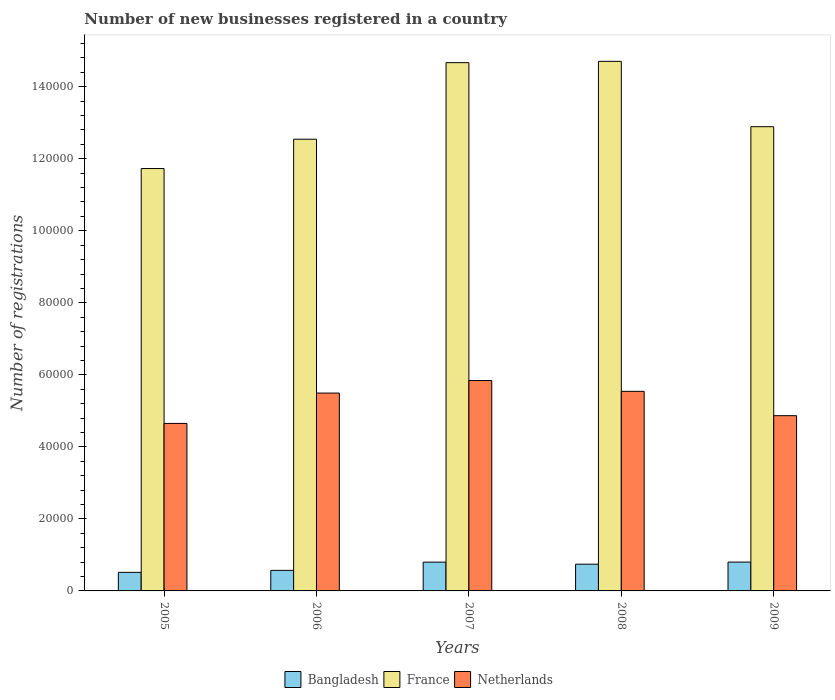How many different coloured bars are there?
Your answer should be very brief. 3. How many groups of bars are there?
Your response must be concise. 5. Are the number of bars per tick equal to the number of legend labels?
Give a very brief answer. Yes. Are the number of bars on each tick of the X-axis equal?
Provide a short and direct response. Yes. How many bars are there on the 5th tick from the left?
Offer a very short reply. 3. How many bars are there on the 1st tick from the right?
Ensure brevity in your answer.  3. What is the label of the 1st group of bars from the left?
Your answer should be compact. 2005. In how many cases, is the number of bars for a given year not equal to the number of legend labels?
Provide a short and direct response. 0. What is the number of new businesses registered in Netherlands in 2009?
Make the answer very short. 4.87e+04. Across all years, what is the maximum number of new businesses registered in Netherlands?
Make the answer very short. 5.84e+04. Across all years, what is the minimum number of new businesses registered in France?
Your response must be concise. 1.17e+05. In which year was the number of new businesses registered in France minimum?
Your answer should be very brief. 2005. What is the total number of new businesses registered in Netherlands in the graph?
Offer a terse response. 2.64e+05. What is the difference between the number of new businesses registered in France in 2006 and that in 2008?
Your response must be concise. -2.16e+04. What is the difference between the number of new businesses registered in Netherlands in 2005 and the number of new businesses registered in Bangladesh in 2006?
Your answer should be very brief. 4.08e+04. What is the average number of new businesses registered in Netherlands per year?
Ensure brevity in your answer.  5.28e+04. In the year 2008, what is the difference between the number of new businesses registered in Netherlands and number of new businesses registered in Bangladesh?
Keep it short and to the point. 4.80e+04. In how many years, is the number of new businesses registered in France greater than 124000?
Ensure brevity in your answer.  4. What is the ratio of the number of new businesses registered in Bangladesh in 2005 to that in 2008?
Offer a very short reply. 0.69. Is the number of new businesses registered in France in 2006 less than that in 2008?
Your answer should be compact. Yes. What is the difference between the highest and the lowest number of new businesses registered in Netherlands?
Give a very brief answer. 1.19e+04. In how many years, is the number of new businesses registered in Bangladesh greater than the average number of new businesses registered in Bangladesh taken over all years?
Provide a short and direct response. 3. Is the sum of the number of new businesses registered in Netherlands in 2006 and 2008 greater than the maximum number of new businesses registered in Bangladesh across all years?
Your answer should be very brief. Yes. What does the 1st bar from the left in 2008 represents?
Provide a short and direct response. Bangladesh. Is it the case that in every year, the sum of the number of new businesses registered in France and number of new businesses registered in Netherlands is greater than the number of new businesses registered in Bangladesh?
Your response must be concise. Yes. Are all the bars in the graph horizontal?
Your answer should be very brief. No. How many years are there in the graph?
Keep it short and to the point. 5. Are the values on the major ticks of Y-axis written in scientific E-notation?
Make the answer very short. No. Where does the legend appear in the graph?
Keep it short and to the point. Bottom center. How are the legend labels stacked?
Your answer should be compact. Horizontal. What is the title of the graph?
Keep it short and to the point. Number of new businesses registered in a country. Does "Guyana" appear as one of the legend labels in the graph?
Provide a short and direct response. No. What is the label or title of the X-axis?
Offer a very short reply. Years. What is the label or title of the Y-axis?
Ensure brevity in your answer.  Number of registrations. What is the Number of registrations of Bangladesh in 2005?
Keep it short and to the point. 5157. What is the Number of registrations of France in 2005?
Provide a succinct answer. 1.17e+05. What is the Number of registrations in Netherlands in 2005?
Give a very brief answer. 4.65e+04. What is the Number of registrations of Bangladesh in 2006?
Your response must be concise. 5707. What is the Number of registrations in France in 2006?
Your answer should be very brief. 1.25e+05. What is the Number of registrations of Netherlands in 2006?
Ensure brevity in your answer.  5.49e+04. What is the Number of registrations of Bangladesh in 2007?
Provide a short and direct response. 7992. What is the Number of registrations of France in 2007?
Ensure brevity in your answer.  1.47e+05. What is the Number of registrations in Netherlands in 2007?
Offer a very short reply. 5.84e+04. What is the Number of registrations of Bangladesh in 2008?
Give a very brief answer. 7425. What is the Number of registrations in France in 2008?
Your answer should be compact. 1.47e+05. What is the Number of registrations of Netherlands in 2008?
Make the answer very short. 5.54e+04. What is the Number of registrations of Bangladesh in 2009?
Make the answer very short. 8007. What is the Number of registrations in France in 2009?
Provide a short and direct response. 1.29e+05. What is the Number of registrations of Netherlands in 2009?
Provide a short and direct response. 4.87e+04. Across all years, what is the maximum Number of registrations in Bangladesh?
Provide a succinct answer. 8007. Across all years, what is the maximum Number of registrations in France?
Your answer should be very brief. 1.47e+05. Across all years, what is the maximum Number of registrations of Netherlands?
Ensure brevity in your answer.  5.84e+04. Across all years, what is the minimum Number of registrations of Bangladesh?
Ensure brevity in your answer.  5157. Across all years, what is the minimum Number of registrations in France?
Give a very brief answer. 1.17e+05. Across all years, what is the minimum Number of registrations of Netherlands?
Give a very brief answer. 4.65e+04. What is the total Number of registrations in Bangladesh in the graph?
Make the answer very short. 3.43e+04. What is the total Number of registrations in France in the graph?
Provide a short and direct response. 6.65e+05. What is the total Number of registrations in Netherlands in the graph?
Provide a short and direct response. 2.64e+05. What is the difference between the Number of registrations in Bangladesh in 2005 and that in 2006?
Make the answer very short. -550. What is the difference between the Number of registrations in France in 2005 and that in 2006?
Offer a terse response. -8145. What is the difference between the Number of registrations of Netherlands in 2005 and that in 2006?
Provide a succinct answer. -8426. What is the difference between the Number of registrations in Bangladesh in 2005 and that in 2007?
Offer a terse response. -2835. What is the difference between the Number of registrations of France in 2005 and that in 2007?
Offer a very short reply. -2.94e+04. What is the difference between the Number of registrations of Netherlands in 2005 and that in 2007?
Offer a very short reply. -1.19e+04. What is the difference between the Number of registrations of Bangladesh in 2005 and that in 2008?
Give a very brief answer. -2268. What is the difference between the Number of registrations in France in 2005 and that in 2008?
Make the answer very short. -2.98e+04. What is the difference between the Number of registrations in Netherlands in 2005 and that in 2008?
Ensure brevity in your answer.  -8905. What is the difference between the Number of registrations of Bangladesh in 2005 and that in 2009?
Provide a succinct answer. -2850. What is the difference between the Number of registrations in France in 2005 and that in 2009?
Offer a very short reply. -1.16e+04. What is the difference between the Number of registrations in Netherlands in 2005 and that in 2009?
Provide a succinct answer. -2146. What is the difference between the Number of registrations in Bangladesh in 2006 and that in 2007?
Keep it short and to the point. -2285. What is the difference between the Number of registrations of France in 2006 and that in 2007?
Provide a short and direct response. -2.13e+04. What is the difference between the Number of registrations in Netherlands in 2006 and that in 2007?
Give a very brief answer. -3487. What is the difference between the Number of registrations in Bangladesh in 2006 and that in 2008?
Offer a very short reply. -1718. What is the difference between the Number of registrations in France in 2006 and that in 2008?
Your response must be concise. -2.16e+04. What is the difference between the Number of registrations of Netherlands in 2006 and that in 2008?
Give a very brief answer. -479. What is the difference between the Number of registrations of Bangladesh in 2006 and that in 2009?
Your answer should be compact. -2300. What is the difference between the Number of registrations in France in 2006 and that in 2009?
Give a very brief answer. -3477. What is the difference between the Number of registrations of Netherlands in 2006 and that in 2009?
Keep it short and to the point. 6280. What is the difference between the Number of registrations in Bangladesh in 2007 and that in 2008?
Provide a short and direct response. 567. What is the difference between the Number of registrations of France in 2007 and that in 2008?
Ensure brevity in your answer.  -363. What is the difference between the Number of registrations in Netherlands in 2007 and that in 2008?
Give a very brief answer. 3008. What is the difference between the Number of registrations in France in 2007 and that in 2009?
Give a very brief answer. 1.78e+04. What is the difference between the Number of registrations of Netherlands in 2007 and that in 2009?
Provide a succinct answer. 9767. What is the difference between the Number of registrations in Bangladesh in 2008 and that in 2009?
Keep it short and to the point. -582. What is the difference between the Number of registrations in France in 2008 and that in 2009?
Offer a terse response. 1.81e+04. What is the difference between the Number of registrations in Netherlands in 2008 and that in 2009?
Your answer should be very brief. 6759. What is the difference between the Number of registrations of Bangladesh in 2005 and the Number of registrations of France in 2006?
Provide a succinct answer. -1.20e+05. What is the difference between the Number of registrations in Bangladesh in 2005 and the Number of registrations in Netherlands in 2006?
Make the answer very short. -4.98e+04. What is the difference between the Number of registrations of France in 2005 and the Number of registrations of Netherlands in 2006?
Keep it short and to the point. 6.23e+04. What is the difference between the Number of registrations in Bangladesh in 2005 and the Number of registrations in France in 2007?
Your response must be concise. -1.42e+05. What is the difference between the Number of registrations of Bangladesh in 2005 and the Number of registrations of Netherlands in 2007?
Provide a short and direct response. -5.33e+04. What is the difference between the Number of registrations of France in 2005 and the Number of registrations of Netherlands in 2007?
Ensure brevity in your answer.  5.89e+04. What is the difference between the Number of registrations of Bangladesh in 2005 and the Number of registrations of France in 2008?
Make the answer very short. -1.42e+05. What is the difference between the Number of registrations in Bangladesh in 2005 and the Number of registrations in Netherlands in 2008?
Keep it short and to the point. -5.03e+04. What is the difference between the Number of registrations in France in 2005 and the Number of registrations in Netherlands in 2008?
Your answer should be compact. 6.19e+04. What is the difference between the Number of registrations in Bangladesh in 2005 and the Number of registrations in France in 2009?
Make the answer very short. -1.24e+05. What is the difference between the Number of registrations of Bangladesh in 2005 and the Number of registrations of Netherlands in 2009?
Your answer should be compact. -4.35e+04. What is the difference between the Number of registrations in France in 2005 and the Number of registrations in Netherlands in 2009?
Make the answer very short. 6.86e+04. What is the difference between the Number of registrations in Bangladesh in 2006 and the Number of registrations in France in 2007?
Offer a very short reply. -1.41e+05. What is the difference between the Number of registrations of Bangladesh in 2006 and the Number of registrations of Netherlands in 2007?
Your response must be concise. -5.27e+04. What is the difference between the Number of registrations in France in 2006 and the Number of registrations in Netherlands in 2007?
Keep it short and to the point. 6.70e+04. What is the difference between the Number of registrations in Bangladesh in 2006 and the Number of registrations in France in 2008?
Offer a terse response. -1.41e+05. What is the difference between the Number of registrations in Bangladesh in 2006 and the Number of registrations in Netherlands in 2008?
Your answer should be compact. -4.97e+04. What is the difference between the Number of registrations in France in 2006 and the Number of registrations in Netherlands in 2008?
Ensure brevity in your answer.  7.00e+04. What is the difference between the Number of registrations in Bangladesh in 2006 and the Number of registrations in France in 2009?
Your response must be concise. -1.23e+05. What is the difference between the Number of registrations in Bangladesh in 2006 and the Number of registrations in Netherlands in 2009?
Provide a short and direct response. -4.30e+04. What is the difference between the Number of registrations in France in 2006 and the Number of registrations in Netherlands in 2009?
Your answer should be very brief. 7.68e+04. What is the difference between the Number of registrations in Bangladesh in 2007 and the Number of registrations in France in 2008?
Provide a succinct answer. -1.39e+05. What is the difference between the Number of registrations in Bangladesh in 2007 and the Number of registrations in Netherlands in 2008?
Provide a short and direct response. -4.74e+04. What is the difference between the Number of registrations in France in 2007 and the Number of registrations in Netherlands in 2008?
Provide a short and direct response. 9.13e+04. What is the difference between the Number of registrations in Bangladesh in 2007 and the Number of registrations in France in 2009?
Provide a succinct answer. -1.21e+05. What is the difference between the Number of registrations in Bangladesh in 2007 and the Number of registrations in Netherlands in 2009?
Keep it short and to the point. -4.07e+04. What is the difference between the Number of registrations of France in 2007 and the Number of registrations of Netherlands in 2009?
Give a very brief answer. 9.80e+04. What is the difference between the Number of registrations in Bangladesh in 2008 and the Number of registrations in France in 2009?
Provide a succinct answer. -1.21e+05. What is the difference between the Number of registrations of Bangladesh in 2008 and the Number of registrations of Netherlands in 2009?
Ensure brevity in your answer.  -4.12e+04. What is the difference between the Number of registrations of France in 2008 and the Number of registrations of Netherlands in 2009?
Your response must be concise. 9.84e+04. What is the average Number of registrations of Bangladesh per year?
Offer a very short reply. 6857.6. What is the average Number of registrations of France per year?
Make the answer very short. 1.33e+05. What is the average Number of registrations of Netherlands per year?
Provide a short and direct response. 5.28e+04. In the year 2005, what is the difference between the Number of registrations in Bangladesh and Number of registrations in France?
Keep it short and to the point. -1.12e+05. In the year 2005, what is the difference between the Number of registrations in Bangladesh and Number of registrations in Netherlands?
Offer a terse response. -4.14e+04. In the year 2005, what is the difference between the Number of registrations in France and Number of registrations in Netherlands?
Provide a succinct answer. 7.08e+04. In the year 2006, what is the difference between the Number of registrations of Bangladesh and Number of registrations of France?
Offer a terse response. -1.20e+05. In the year 2006, what is the difference between the Number of registrations of Bangladesh and Number of registrations of Netherlands?
Your response must be concise. -4.92e+04. In the year 2006, what is the difference between the Number of registrations of France and Number of registrations of Netherlands?
Give a very brief answer. 7.05e+04. In the year 2007, what is the difference between the Number of registrations of Bangladesh and Number of registrations of France?
Make the answer very short. -1.39e+05. In the year 2007, what is the difference between the Number of registrations in Bangladesh and Number of registrations in Netherlands?
Your answer should be very brief. -5.04e+04. In the year 2007, what is the difference between the Number of registrations of France and Number of registrations of Netherlands?
Offer a terse response. 8.83e+04. In the year 2008, what is the difference between the Number of registrations of Bangladesh and Number of registrations of France?
Keep it short and to the point. -1.40e+05. In the year 2008, what is the difference between the Number of registrations of Bangladesh and Number of registrations of Netherlands?
Your answer should be very brief. -4.80e+04. In the year 2008, what is the difference between the Number of registrations of France and Number of registrations of Netherlands?
Your answer should be compact. 9.16e+04. In the year 2009, what is the difference between the Number of registrations in Bangladesh and Number of registrations in France?
Give a very brief answer. -1.21e+05. In the year 2009, what is the difference between the Number of registrations of Bangladesh and Number of registrations of Netherlands?
Keep it short and to the point. -4.07e+04. In the year 2009, what is the difference between the Number of registrations in France and Number of registrations in Netherlands?
Ensure brevity in your answer.  8.02e+04. What is the ratio of the Number of registrations of Bangladesh in 2005 to that in 2006?
Your response must be concise. 0.9. What is the ratio of the Number of registrations in France in 2005 to that in 2006?
Provide a succinct answer. 0.94. What is the ratio of the Number of registrations in Netherlands in 2005 to that in 2006?
Provide a short and direct response. 0.85. What is the ratio of the Number of registrations of Bangladesh in 2005 to that in 2007?
Provide a short and direct response. 0.65. What is the ratio of the Number of registrations of France in 2005 to that in 2007?
Make the answer very short. 0.8. What is the ratio of the Number of registrations of Netherlands in 2005 to that in 2007?
Make the answer very short. 0.8. What is the ratio of the Number of registrations in Bangladesh in 2005 to that in 2008?
Keep it short and to the point. 0.69. What is the ratio of the Number of registrations of France in 2005 to that in 2008?
Keep it short and to the point. 0.8. What is the ratio of the Number of registrations in Netherlands in 2005 to that in 2008?
Keep it short and to the point. 0.84. What is the ratio of the Number of registrations in Bangladesh in 2005 to that in 2009?
Keep it short and to the point. 0.64. What is the ratio of the Number of registrations of France in 2005 to that in 2009?
Your response must be concise. 0.91. What is the ratio of the Number of registrations of Netherlands in 2005 to that in 2009?
Ensure brevity in your answer.  0.96. What is the ratio of the Number of registrations in Bangladesh in 2006 to that in 2007?
Offer a terse response. 0.71. What is the ratio of the Number of registrations of France in 2006 to that in 2007?
Your answer should be very brief. 0.86. What is the ratio of the Number of registrations of Netherlands in 2006 to that in 2007?
Provide a short and direct response. 0.94. What is the ratio of the Number of registrations of Bangladesh in 2006 to that in 2008?
Give a very brief answer. 0.77. What is the ratio of the Number of registrations of France in 2006 to that in 2008?
Ensure brevity in your answer.  0.85. What is the ratio of the Number of registrations of Netherlands in 2006 to that in 2008?
Provide a short and direct response. 0.99. What is the ratio of the Number of registrations in Bangladesh in 2006 to that in 2009?
Ensure brevity in your answer.  0.71. What is the ratio of the Number of registrations of Netherlands in 2006 to that in 2009?
Your answer should be compact. 1.13. What is the ratio of the Number of registrations of Bangladesh in 2007 to that in 2008?
Your answer should be very brief. 1.08. What is the ratio of the Number of registrations in France in 2007 to that in 2008?
Provide a succinct answer. 1. What is the ratio of the Number of registrations in Netherlands in 2007 to that in 2008?
Your answer should be very brief. 1.05. What is the ratio of the Number of registrations of Bangladesh in 2007 to that in 2009?
Keep it short and to the point. 1. What is the ratio of the Number of registrations of France in 2007 to that in 2009?
Give a very brief answer. 1.14. What is the ratio of the Number of registrations in Netherlands in 2007 to that in 2009?
Offer a very short reply. 1.2. What is the ratio of the Number of registrations in Bangladesh in 2008 to that in 2009?
Keep it short and to the point. 0.93. What is the ratio of the Number of registrations in France in 2008 to that in 2009?
Ensure brevity in your answer.  1.14. What is the ratio of the Number of registrations in Netherlands in 2008 to that in 2009?
Your answer should be very brief. 1.14. What is the difference between the highest and the second highest Number of registrations of France?
Offer a terse response. 363. What is the difference between the highest and the second highest Number of registrations of Netherlands?
Ensure brevity in your answer.  3008. What is the difference between the highest and the lowest Number of registrations in Bangladesh?
Your response must be concise. 2850. What is the difference between the highest and the lowest Number of registrations in France?
Ensure brevity in your answer.  2.98e+04. What is the difference between the highest and the lowest Number of registrations in Netherlands?
Keep it short and to the point. 1.19e+04. 